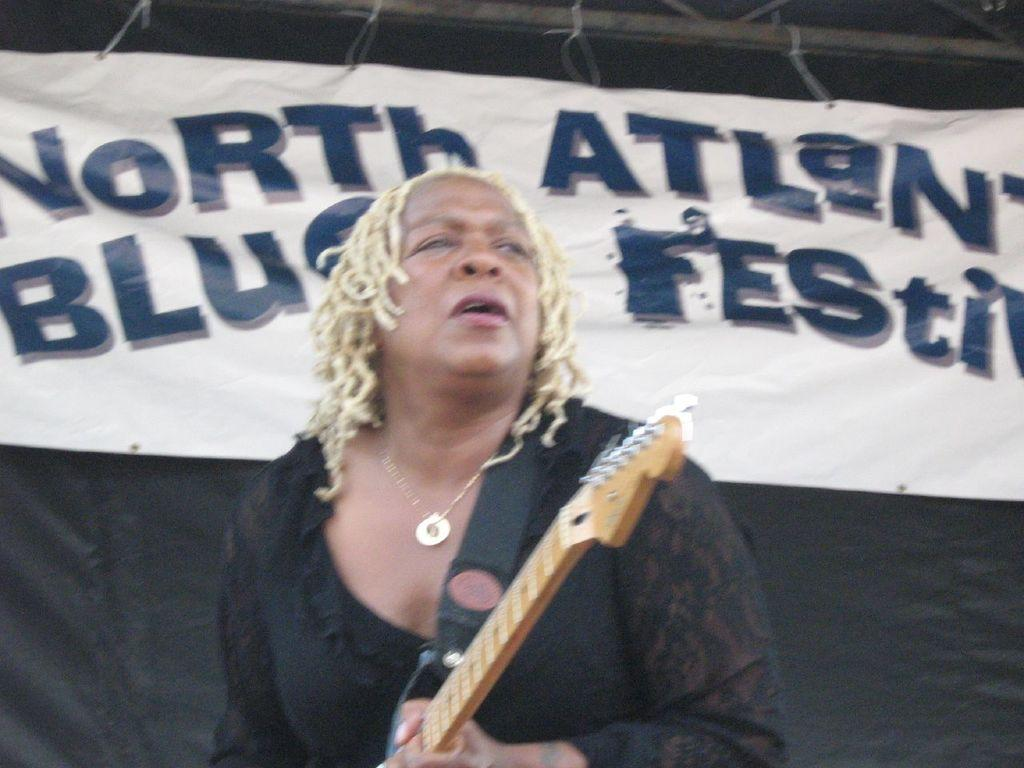What is the person in the image doing? The person is holding a guitar and appears to be singing, as their mouth is open. What object is the person holding in the image? The person is holding a guitar in the image. What can be seen in the background of the image? There is a banner visible in the background of the image. How many chairs are present in the image? There are no chairs visible in the image. What type of substance is the person using to play the guitar in the image? The person is not using any substance to play the guitar; they are simply holding it. 